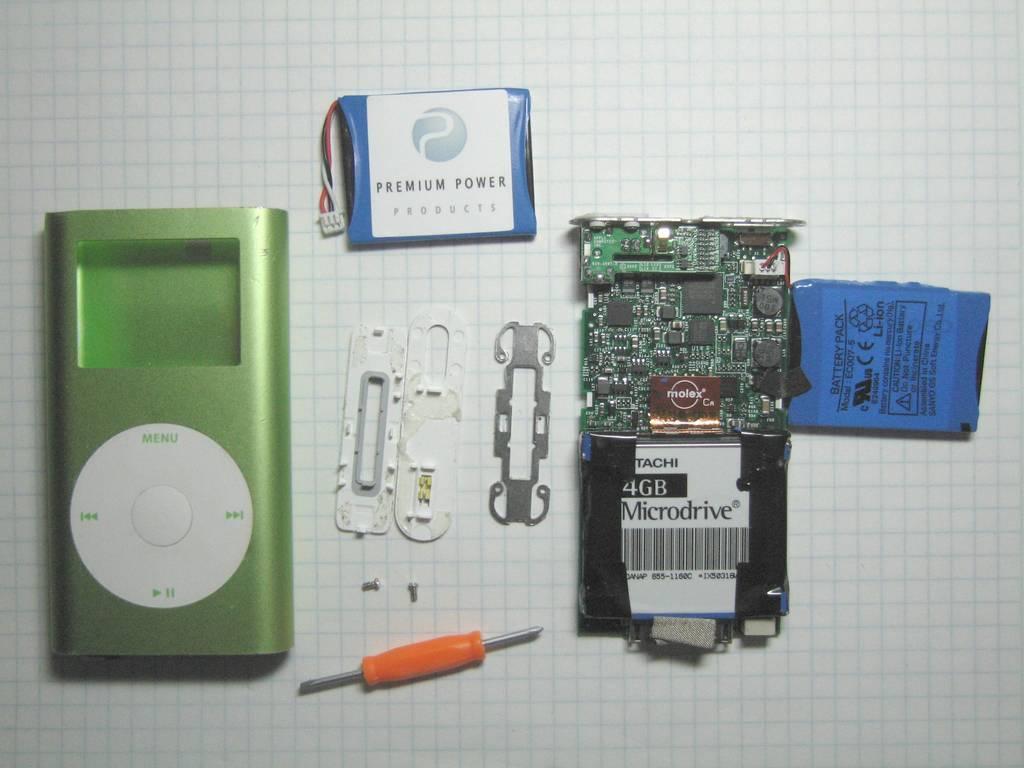Could you give a brief overview of what you see in this image? In this image there is the wall, on which there is a screw driver, chipboard, remote, some other objects attached to it. 